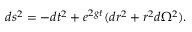Convert formula to latex. <formula><loc_0><loc_0><loc_500><loc_500>d s ^ { 2 } = - d t ^ { 2 } + e ^ { 2 g t } ( d r ^ { 2 } + r ^ { 2 } d \Omega ^ { 2 } ) .</formula> 